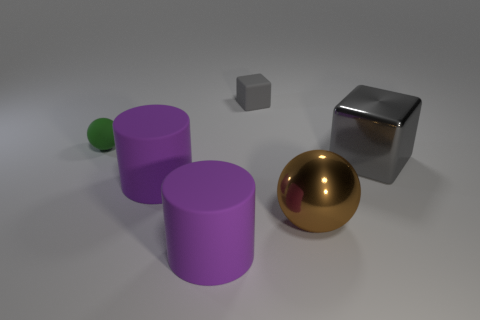Is the shape of the purple rubber thing that is behind the large brown ball the same as the gray matte object? The purple object behind the large brown ball appears to be a cylindrical shape, while the gray object is a cube. Therefore, their shapes are not the same—one is a three-dimensional rectangle with equal sides, and the other has a circular top with straight sides. 